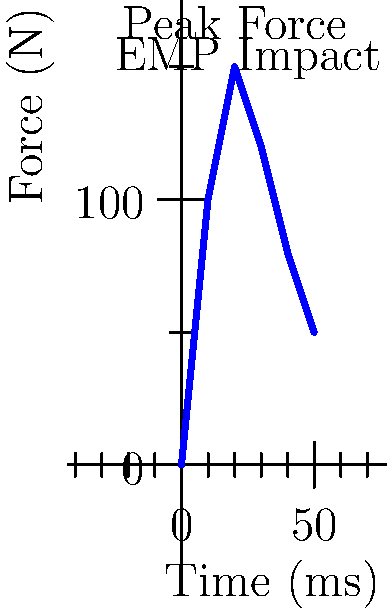Based on the graph showing the force experienced by a power plant worker during an EMP attack, what is the maximum force exerted on the worker's body, and at approximately what time does this peak occur? How might this impact the worker's biomechanics? To answer this question, we need to analyze the graph and understand its implications:

1. Interpret the axes:
   - X-axis represents Time in milliseconds (ms)
   - Y-axis represents Force in Newtons (N)

2. Identify the peak force:
   - The highest point on the curve represents the maximum force
   - This occurs at approximately 20 ms
   - The force at this point is 150 N

3. Understand the biomechanical impact:
   - The rapid increase in force (0 to 150 N in 20 ms) indicates a sudden impact
   - This sudden force could cause:
     a) Muscle contractions or spasms
     b) Potential loss of balance or falls
     c) Possible strain on joints, especially if the worker is in an awkward position

4. Consider the duration:
   - The force decreases after the peak but remains elevated for some time
   - This prolonged exposure, even at lower forces, could lead to fatigue or strain

5. Relate to EMP effects:
   - EMPs typically don't directly exert physical force on humans
   - The force graph likely represents secondary effects, such as:
     a) Sudden movement of metallic objects
     b) Electrical equipment malfunctions causing physical reactions
     c) Potential muscle contractions due to induced currents in the body

6. Safety implications:
   - Understanding this force profile is crucial for developing protective measures
   - It highlights the need for proper grounding and shielding in power plant environments
Answer: Maximum force: 150 N at 20 ms. Potential impacts: sudden muscle contractions, loss of balance, joint strain. 